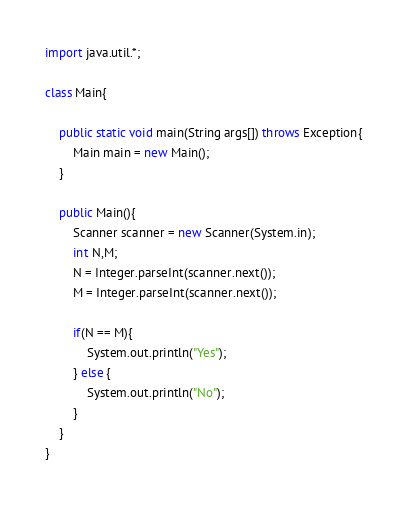Convert code to text. <code><loc_0><loc_0><loc_500><loc_500><_Java_>import java.util.*;

class Main{

    public static void main(String args[]) throws Exception{
        Main main = new Main();
    }

    public Main(){
        Scanner scanner = new Scanner(System.in);
        int N,M;
        N = Integer.parseInt(scanner.next());
        M = Integer.parseInt(scanner.next());

        if(N == M){
            System.out.println("Yes");
        } else {
            System.out.println("No");
        }
    }
}
</code> 